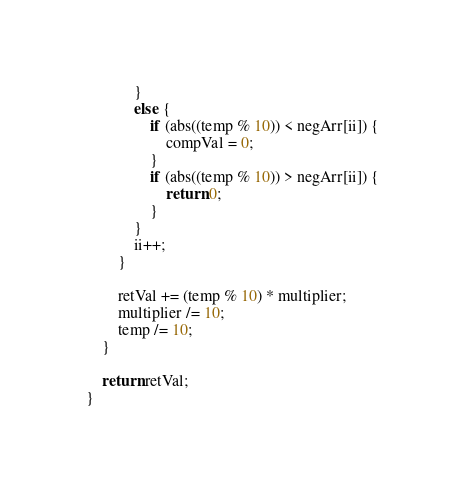<code> <loc_0><loc_0><loc_500><loc_500><_C_>			}
			else {
				if (abs((temp % 10)) < negArr[ii]) {
					compVal = 0;
				}
				if (abs((temp % 10)) > negArr[ii]) {
					return 0;
				}
			}
			ii++;
		}

		retVal += (temp % 10) * multiplier;
		multiplier /= 10;
		temp /= 10;
	}

	return retVal;
}</code> 